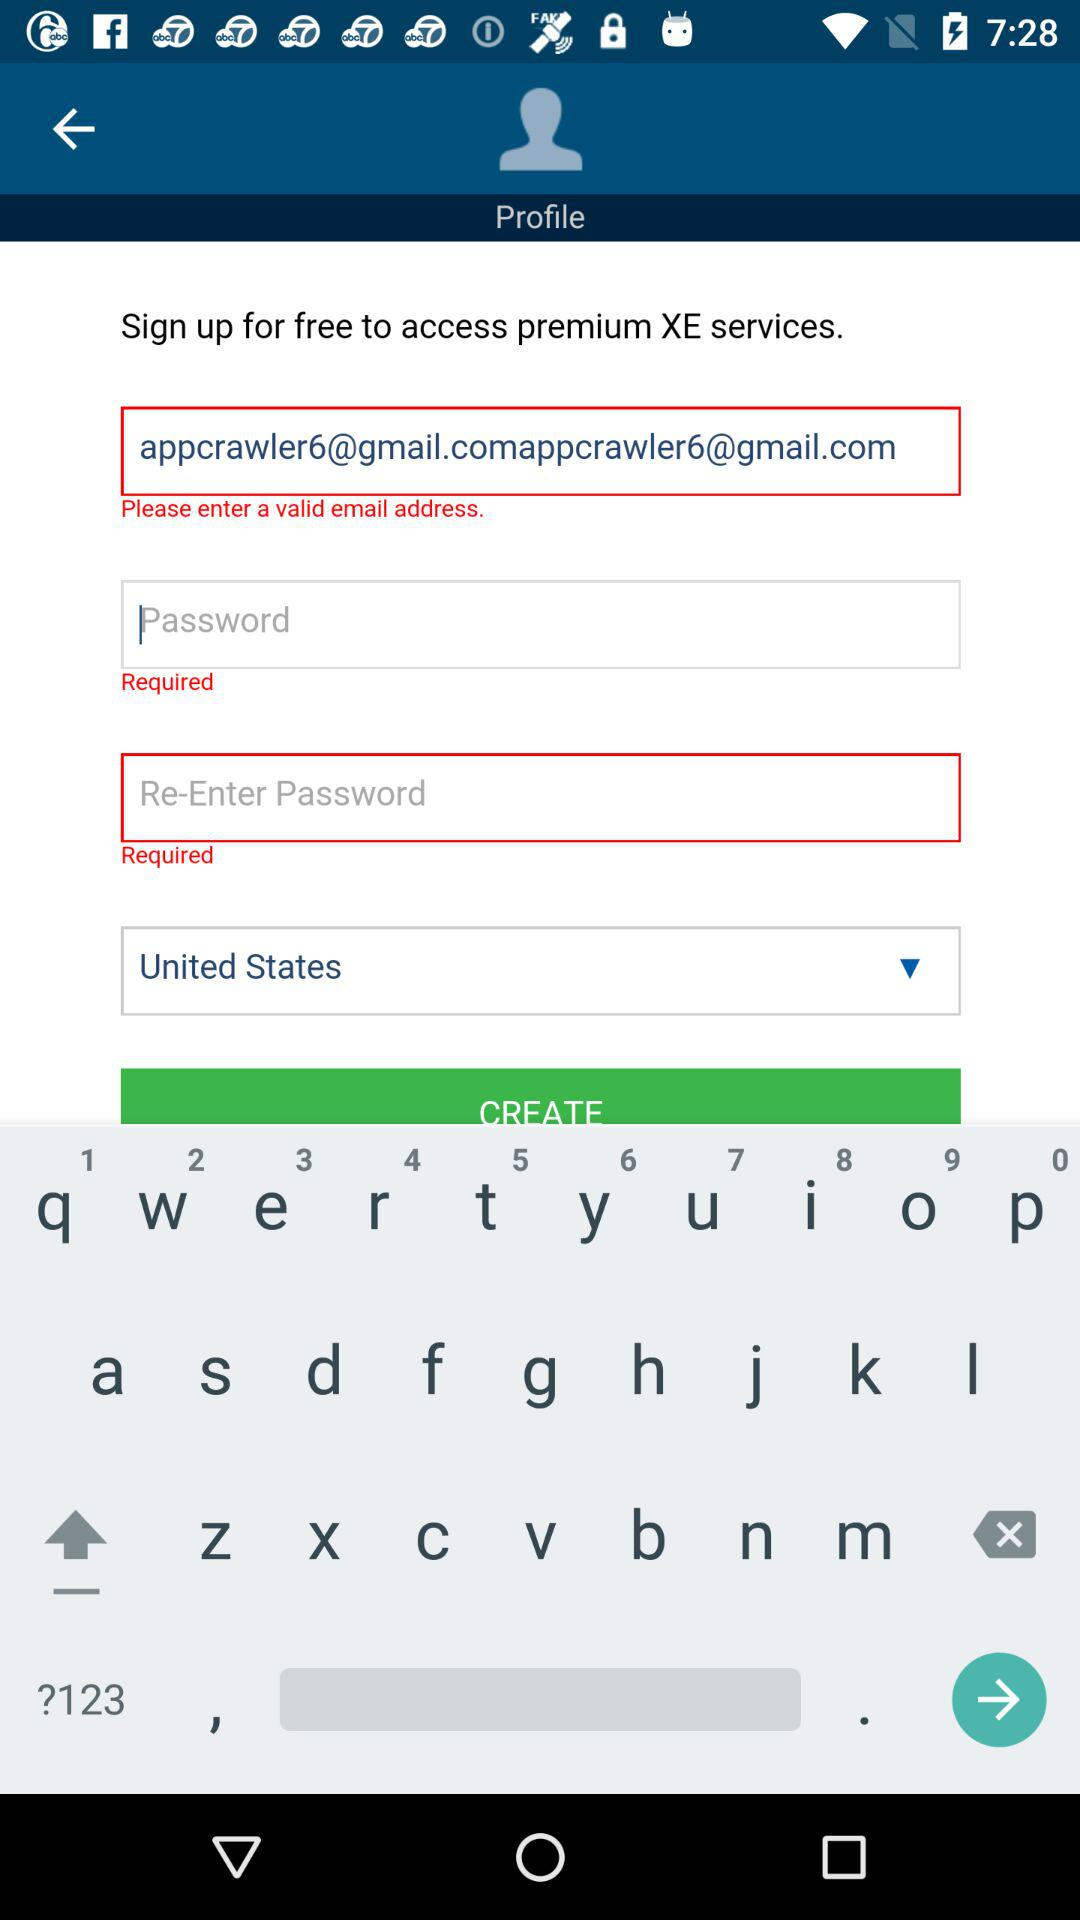For what action are we signing up? You are signing up to access premium XE services. 